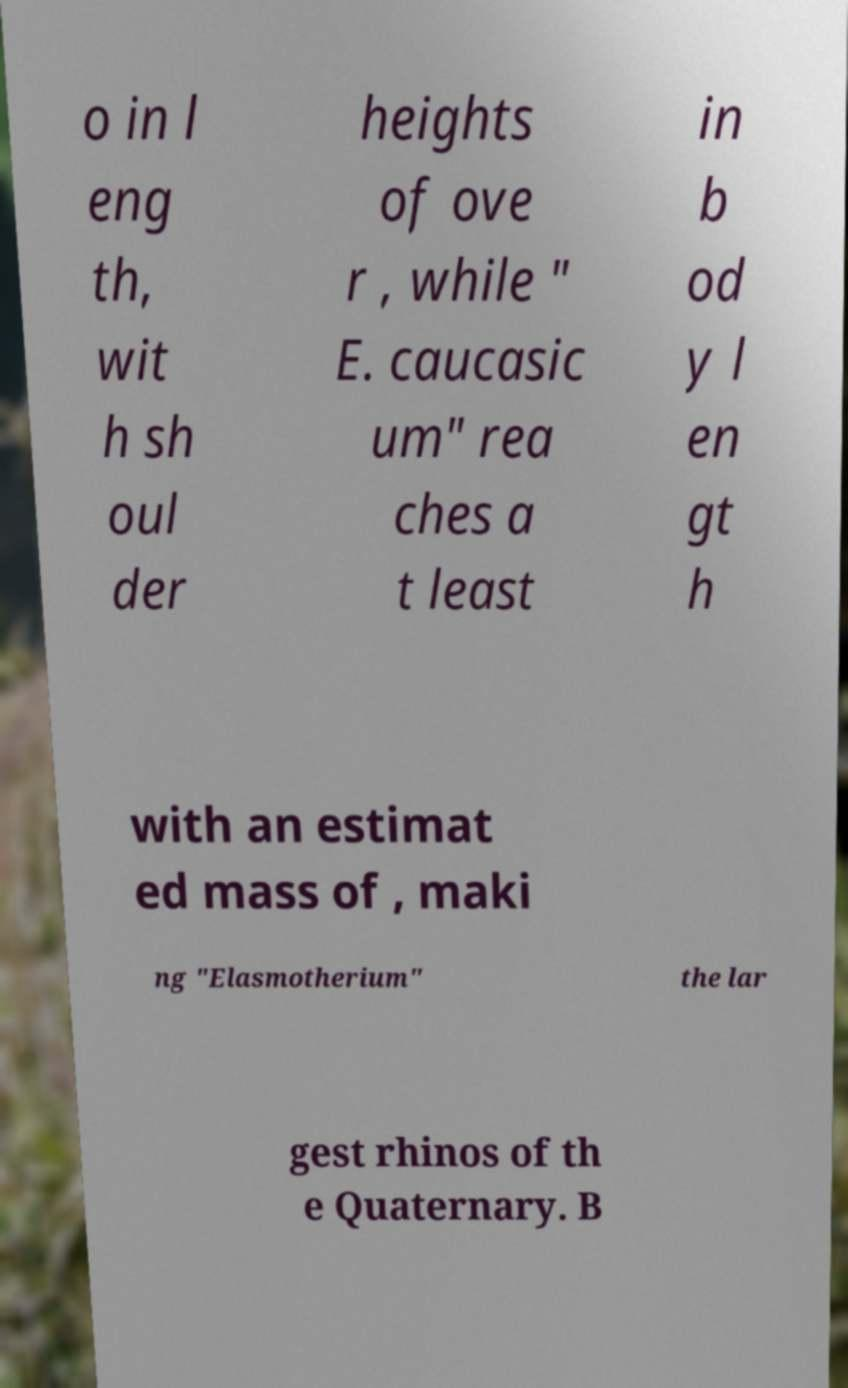Please identify and transcribe the text found in this image. o in l eng th, wit h sh oul der heights of ove r , while " E. caucasic um" rea ches a t least in b od y l en gt h with an estimat ed mass of , maki ng "Elasmotherium" the lar gest rhinos of th e Quaternary. B 